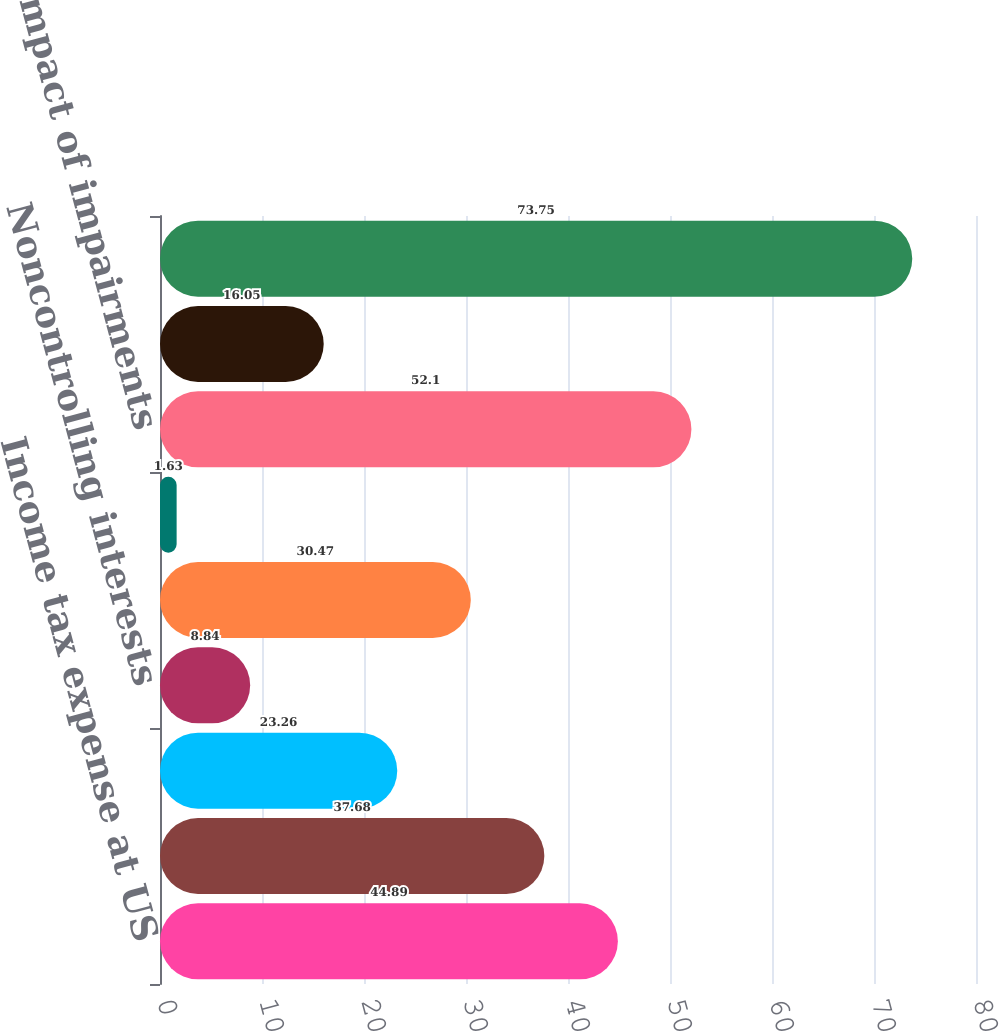Convert chart to OTSL. <chart><loc_0><loc_0><loc_500><loc_500><bar_chart><fcel>Income tax expense at US<fcel>Federal tax credits<fcel>Taxing authority audit<fcel>Noncontrolling interests<fcel>State and local income taxes<fcel>Tax rate differential on<fcel>Tax impact of impairments<fcel>Other<fcel>Provision for income taxes<nl><fcel>44.89<fcel>37.68<fcel>23.26<fcel>8.84<fcel>30.47<fcel>1.63<fcel>52.1<fcel>16.05<fcel>73.75<nl></chart> 